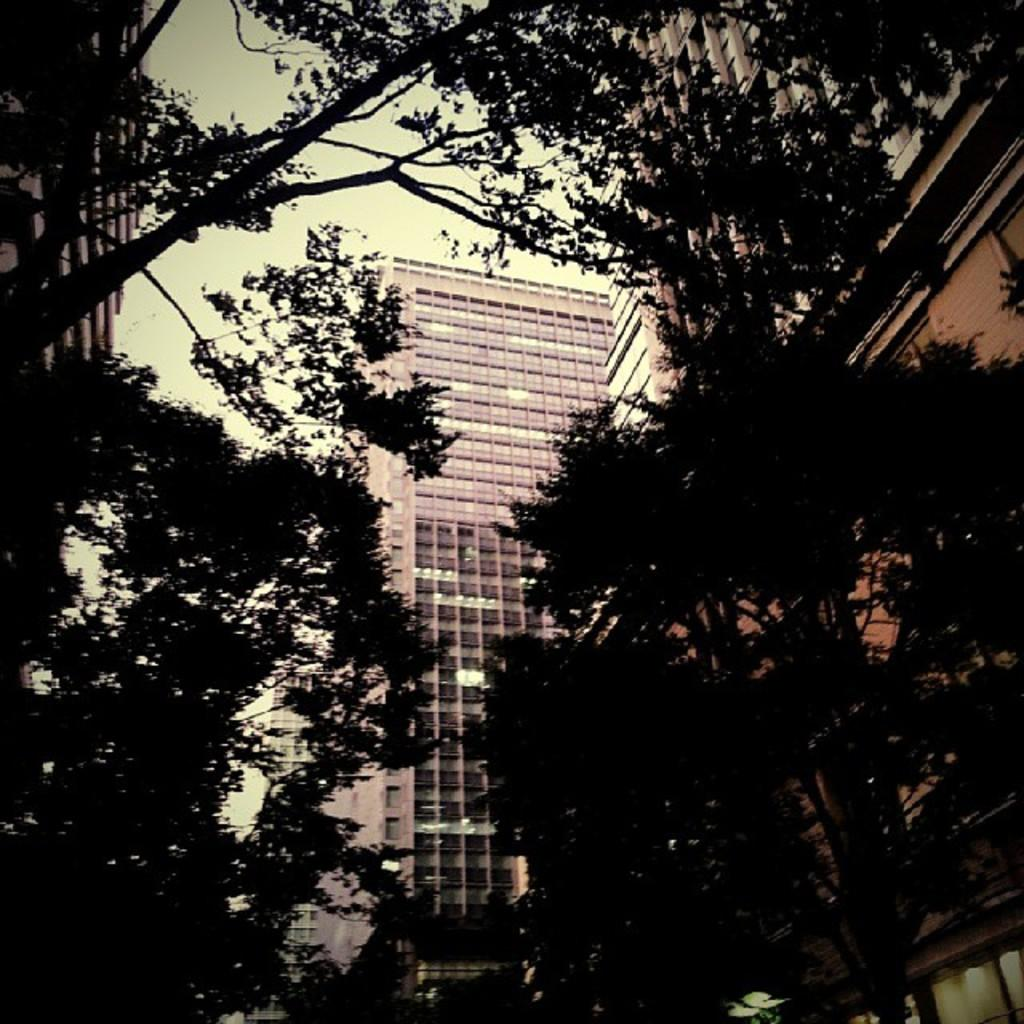What type of natural elements can be seen in the background of the image? There are trees in the background of the image. What type of man-made structures can be seen in the background of the image? There are buildings in the background of the image. How many insects can be seen flying around the trees in the image? There are no insects visible in the image; it only features trees and buildings in the background. 